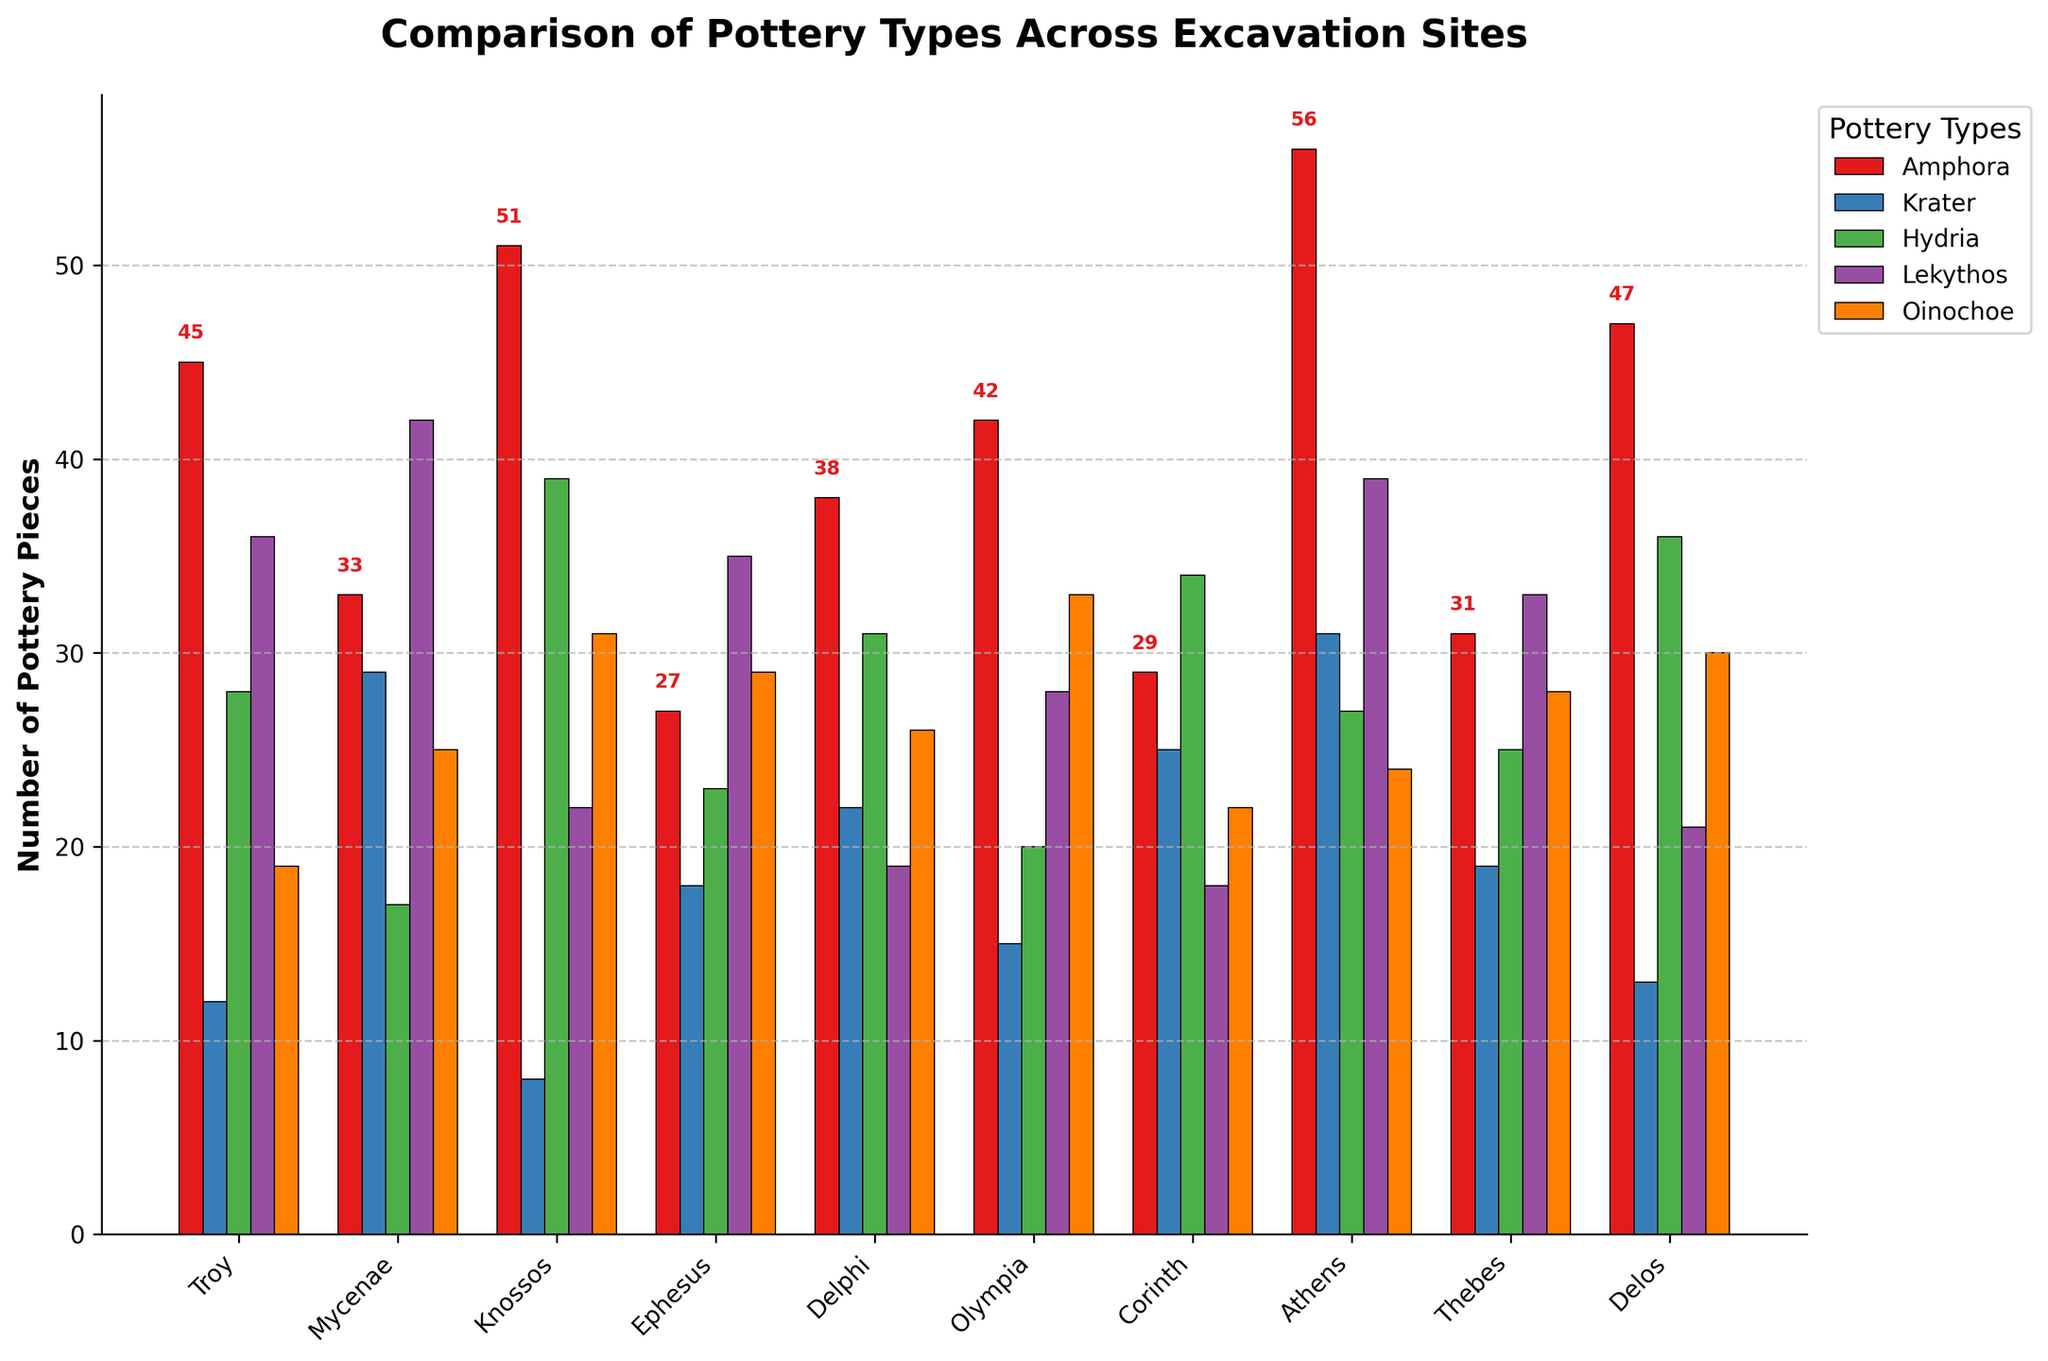Which site has the highest number of Amphora pieces? Looking at the bar heights for Amphora pieces, which are represented by red bars, Athens clearly has the tallest bar. Therefore, Athens has the highest number of Amphora pieces.
Answer: Athens Which pottery type is most common at Troy? By comparing the heights of the bars for each pottery type at Troy, the Amphora bar is the tallest. Thus, Amphora is the most common pottery type at Troy.
Answer: Amphora What is the total number of Krater pieces found at Mycenae and Ephesus combined? Mycenae has 29 Krater pieces and Ephesus has 18 Krater pieces. Adding them together gives 29 + 18 = 47.
Answer: 47 Which site has the lowest number of Lekythos pieces? By examining the heights of the bars for Lekythos pieces across all sites, Krater has the shortest bar in Knossos with 22 pieces. However, Knossos has a shorter bar for Lekythos with 18 pieces, making Knossos the site with the lowest number of Lekythos pieces.
Answer: Knossos Which site has a higher number of Oinochoe pieces, Olympia or Thebes? Comparing the heights of the orange bars representing Oinochoe pieces in Olympia and Thebes, Olympia has 33 Oinochoe pieces, while Thebes has 28. Thus, Olympia has a higher number of Oinochoe pieces.
Answer: Olympia What is the overall average number of Hydria pieces found across all sites? Adding the Hydria pieces across all sites: 28 + 17 + 39 + 23 + 31 + 20 + 34 + 27 + 25 + 36 = 280. Dividing by the number of sites (10) gives 280 / 10 = 28.
Answer: 28 How many more Lekythos pieces are found at Athens compared to Delphi? Athens has 39 Lekythos pieces and Delphi has 19. The difference is 39 - 19 = 20.
Answer: 20 Which site has the highest total number of pottery pieces when combining all types? We need to sum all pottery pieces for each site and identify the highest:
Troy: 45 + 12 + 28 + 36 + 19 = 140
Mycenae: 33 + 29 + 17 + 42 + 25 = 146
Knossos: 51 + 8 + 39 + 22 + 31 = 151
Ephesus: 27 + 18 + 23 + 35 + 29 = 132
Delphi: 38 + 22 + 31 + 19 + 26 = 136
Olympia: 42 + 15 + 20 + 28 + 33 = 138
Corinth: 29 + 25 + 34 + 18 + 22 = 128
Athens: 56 + 31 + 27 + 39 + 24 = 177
Thebes: 31 + 19 + 25 + 33 + 28 = 136
Delos: 47 + 13 + 36 + 21 + 30 = 147
Athens has the highest total with 177 pieces.
Answer: Athens 